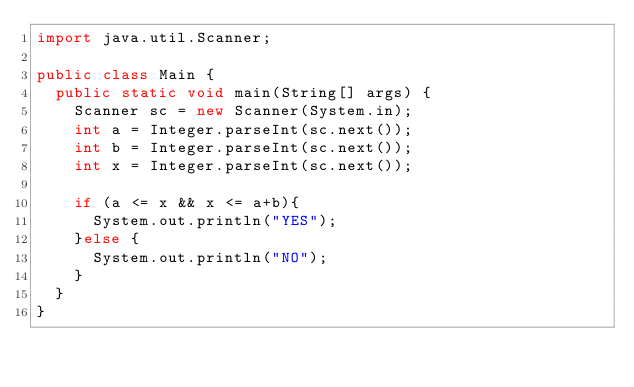<code> <loc_0><loc_0><loc_500><loc_500><_Java_>import java.util.Scanner;

public class Main {
	public static void main(String[] args) {
		Scanner sc = new Scanner(System.in);
		int a = Integer.parseInt(sc.next());
		int b = Integer.parseInt(sc.next());
		int x = Integer.parseInt(sc.next());

		if (a <= x && x <= a+b){
			System.out.println("YES");
		}else {
			System.out.println("NO");
		}
	}
}
</code> 